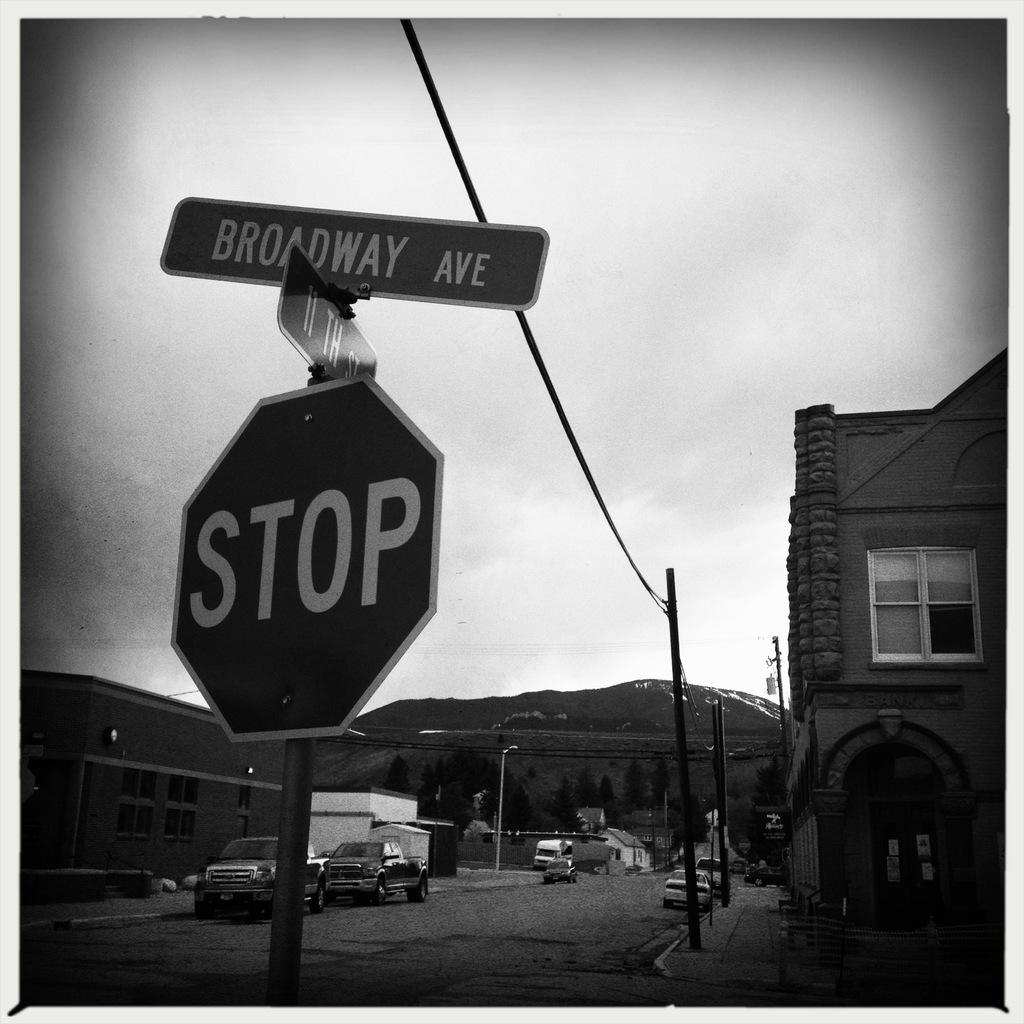<image>
Render a clear and concise summary of the photo. stop sign and street sign placed in the street 